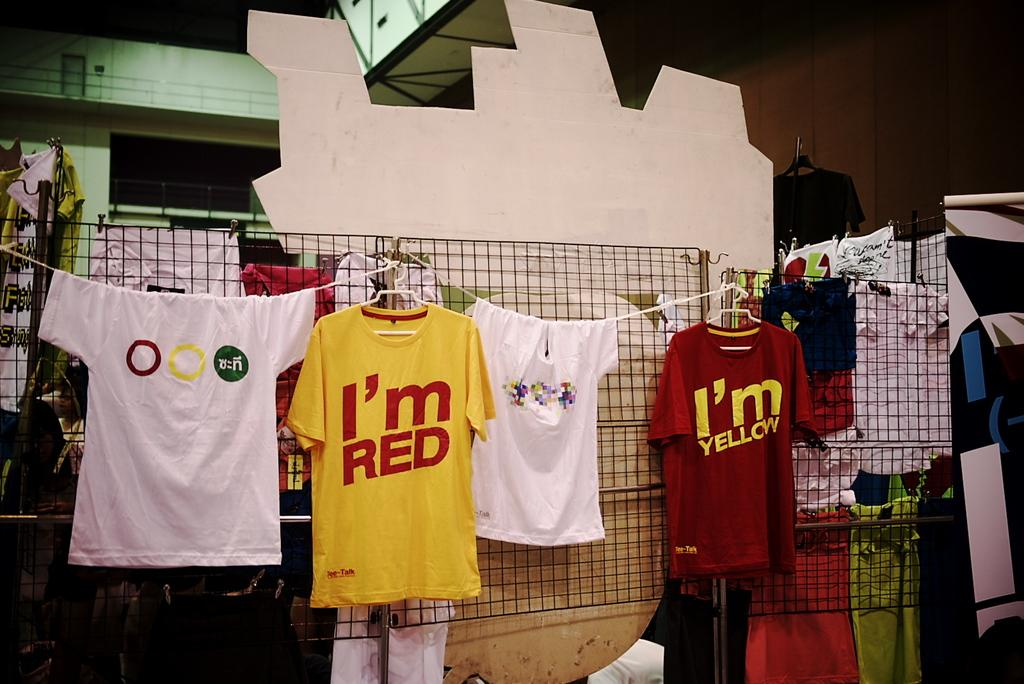<image>
Create a compact narrative representing the image presented. "I'm Red" and "I'm Yellow" T-Shirts displayed on a clothesline. 